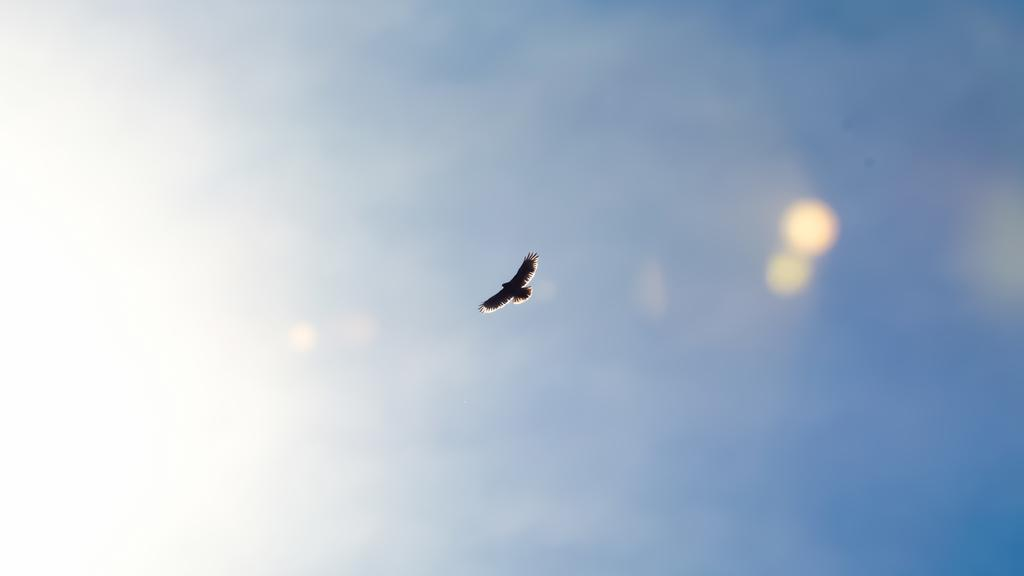What type of animal can be seen in the image? There is a bird in the image. What is the bird doing in the image? The bird is flying in the air. What part of the natural environment is visible in the image? The sky is visible in the image. Where is the grandmother having trouble with her fishing pole at the lake in the image? There is no grandmother, fishing pole, or lake present in the image; it features a bird flying in the sky. 